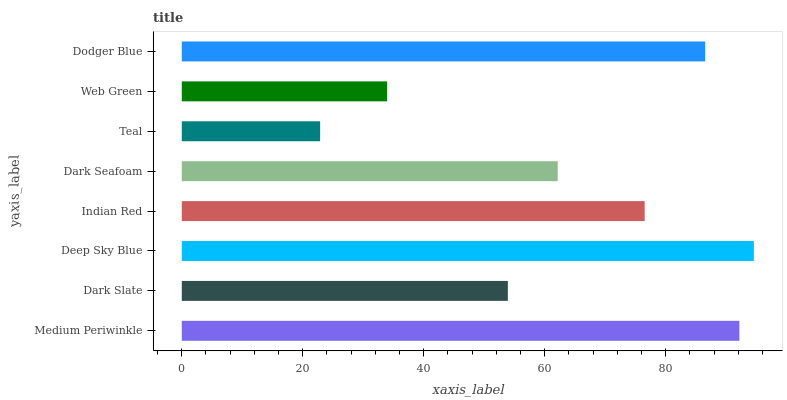Is Teal the minimum?
Answer yes or no. Yes. Is Deep Sky Blue the maximum?
Answer yes or no. Yes. Is Dark Slate the minimum?
Answer yes or no. No. Is Dark Slate the maximum?
Answer yes or no. No. Is Medium Periwinkle greater than Dark Slate?
Answer yes or no. Yes. Is Dark Slate less than Medium Periwinkle?
Answer yes or no. Yes. Is Dark Slate greater than Medium Periwinkle?
Answer yes or no. No. Is Medium Periwinkle less than Dark Slate?
Answer yes or no. No. Is Indian Red the high median?
Answer yes or no. Yes. Is Dark Seafoam the low median?
Answer yes or no. Yes. Is Dark Seafoam the high median?
Answer yes or no. No. Is Indian Red the low median?
Answer yes or no. No. 